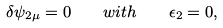Convert formula to latex. <formula><loc_0><loc_0><loc_500><loc_500>\delta \psi _ { 2 \mu } = 0 \quad w i t h \quad \epsilon _ { 2 } = 0 ,</formula> 